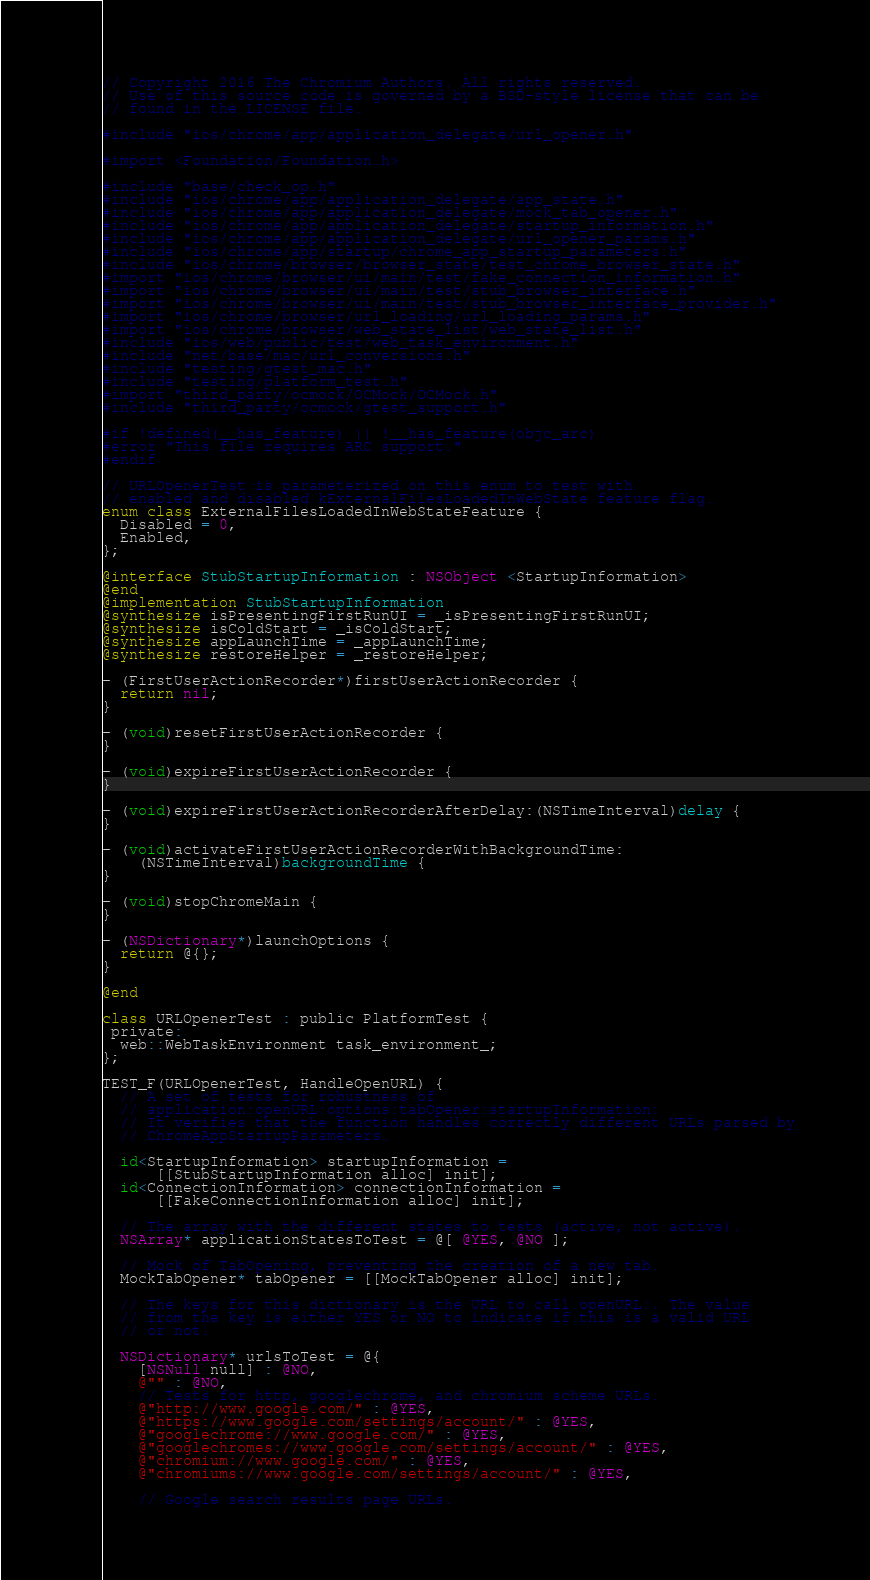Convert code to text. <code><loc_0><loc_0><loc_500><loc_500><_ObjectiveC_>// Copyright 2016 The Chromium Authors. All rights reserved.
// Use of this source code is governed by a BSD-style license that can be
// found in the LICENSE file.

#include "ios/chrome/app/application_delegate/url_opener.h"

#import <Foundation/Foundation.h>

#include "base/check_op.h"
#include "ios/chrome/app/application_delegate/app_state.h"
#include "ios/chrome/app/application_delegate/mock_tab_opener.h"
#include "ios/chrome/app/application_delegate/startup_information.h"
#include "ios/chrome/app/application_delegate/url_opener_params.h"
#include "ios/chrome/app/startup/chrome_app_startup_parameters.h"
#include "ios/chrome/browser/browser_state/test_chrome_browser_state.h"
#import "ios/chrome/browser/ui/main/test/fake_connection_information.h"
#import "ios/chrome/browser/ui/main/test/stub_browser_interface.h"
#import "ios/chrome/browser/ui/main/test/stub_browser_interface_provider.h"
#import "ios/chrome/browser/url_loading/url_loading_params.h"
#import "ios/chrome/browser/web_state_list/web_state_list.h"
#include "ios/web/public/test/web_task_environment.h"
#include "net/base/mac/url_conversions.h"
#include "testing/gtest_mac.h"
#include "testing/platform_test.h"
#import "third_party/ocmock/OCMock/OCMock.h"
#include "third_party/ocmock/gtest_support.h"

#if !defined(__has_feature) || !__has_feature(objc_arc)
#error "This file requires ARC support."
#endif

// URLOpenerTest is parameterized on this enum to test with
// enabled and disabled kExternalFilesLoadedInWebState feature flag.
enum class ExternalFilesLoadedInWebStateFeature {
  Disabled = 0,
  Enabled,
};

@interface StubStartupInformation : NSObject <StartupInformation>
@end
@implementation StubStartupInformation
@synthesize isPresentingFirstRunUI = _isPresentingFirstRunUI;
@synthesize isColdStart = _isColdStart;
@synthesize appLaunchTime = _appLaunchTime;
@synthesize restoreHelper = _restoreHelper;

- (FirstUserActionRecorder*)firstUserActionRecorder {
  return nil;
}

- (void)resetFirstUserActionRecorder {
}

- (void)expireFirstUserActionRecorder {
}

- (void)expireFirstUserActionRecorderAfterDelay:(NSTimeInterval)delay {
}

- (void)activateFirstUserActionRecorderWithBackgroundTime:
    (NSTimeInterval)backgroundTime {
}

- (void)stopChromeMain {
}

- (NSDictionary*)launchOptions {
  return @{};
}

@end

class URLOpenerTest : public PlatformTest {
 private:
  web::WebTaskEnvironment task_environment_;
};

TEST_F(URLOpenerTest, HandleOpenURL) {
  // A set of tests for robustness of
  // application:openURL:options:tabOpener:startupInformation:
  // It verifies that the function handles correctly different URLs parsed by
  // ChromeAppStartupParameters.

  id<StartupInformation> startupInformation =
      [[StubStartupInformation alloc] init];
  id<ConnectionInformation> connectionInformation =
      [[FakeConnectionInformation alloc] init];

  // The array with the different states to tests (active, not active).
  NSArray* applicationStatesToTest = @[ @YES, @NO ];

  // Mock of TabOpening, preventing the creation of a new tab.
  MockTabOpener* tabOpener = [[MockTabOpener alloc] init];

  // The keys for this dictionary is the URL to call openURL:. The value
  // from the key is either YES or NO to indicate if this is a valid URL
  // or not.

  NSDictionary* urlsToTest = @{
    [NSNull null] : @NO,
    @"" : @NO,
    // Tests for http, googlechrome, and chromium scheme URLs.
    @"http://www.google.com/" : @YES,
    @"https://www.google.com/settings/account/" : @YES,
    @"googlechrome://www.google.com/" : @YES,
    @"googlechromes://www.google.com/settings/account/" : @YES,
    @"chromium://www.google.com/" : @YES,
    @"chromiums://www.google.com/settings/account/" : @YES,

    // Google search results page URLs.</code> 